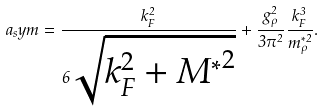Convert formula to latex. <formula><loc_0><loc_0><loc_500><loc_500>a _ { s } y m = \frac { k _ { F } ^ { 2 } } { 6 \sqrt { k _ { F } ^ { 2 } + { M ^ { \ast } } ^ { 2 } } } + \frac { g _ { \rho } ^ { 2 } } { 3 \pi ^ { 2 } } \frac { k _ { F } ^ { 3 } } { m _ { \rho } ^ { \ast 2 } } .</formula> 